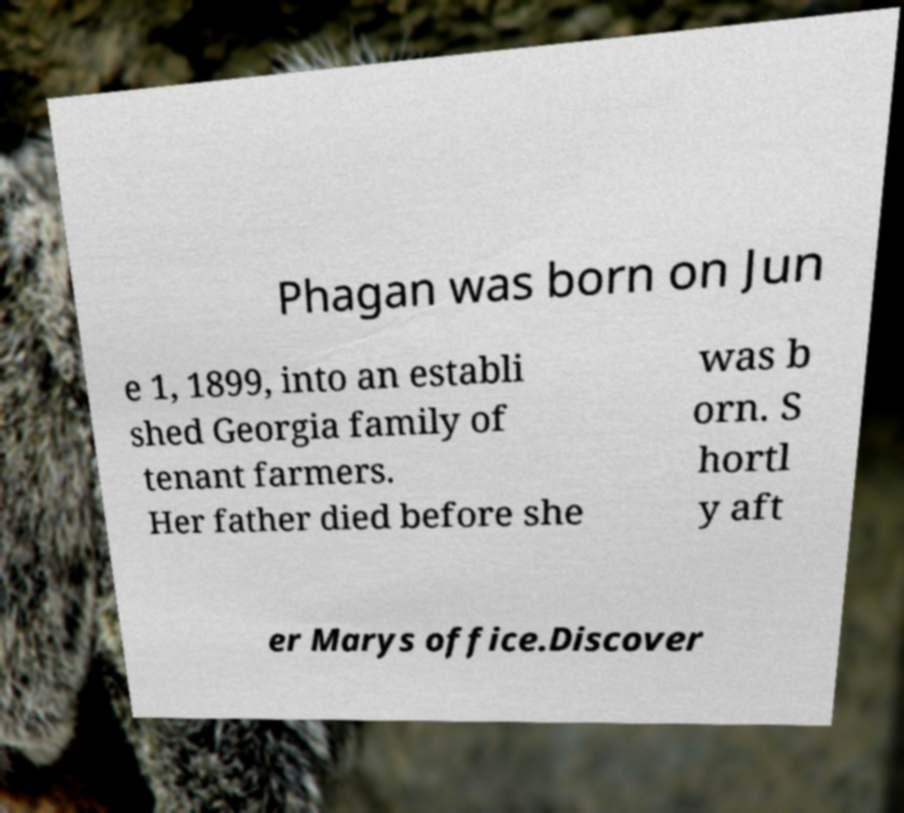Could you extract and type out the text from this image? Phagan was born on Jun e 1, 1899, into an establi shed Georgia family of tenant farmers. Her father died before she was b orn. S hortl y aft er Marys office.Discover 